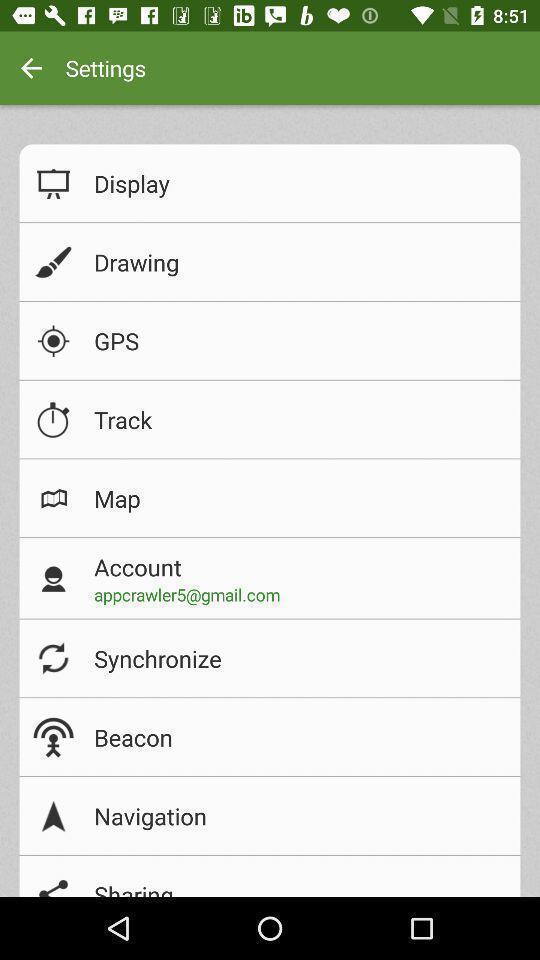Provide a description of this screenshot. Page showing a variety of settings. 